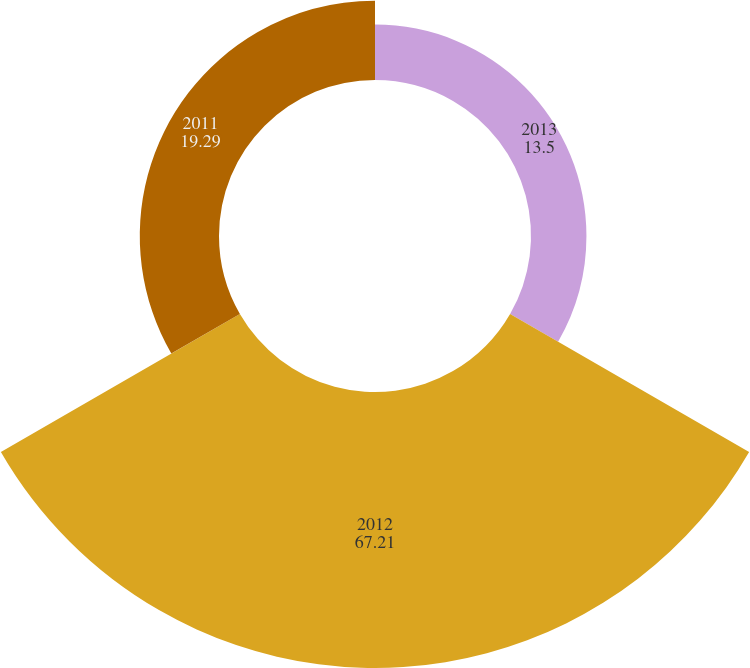<chart> <loc_0><loc_0><loc_500><loc_500><pie_chart><fcel>2013<fcel>2012<fcel>2011<nl><fcel>13.5%<fcel>67.21%<fcel>19.29%<nl></chart> 